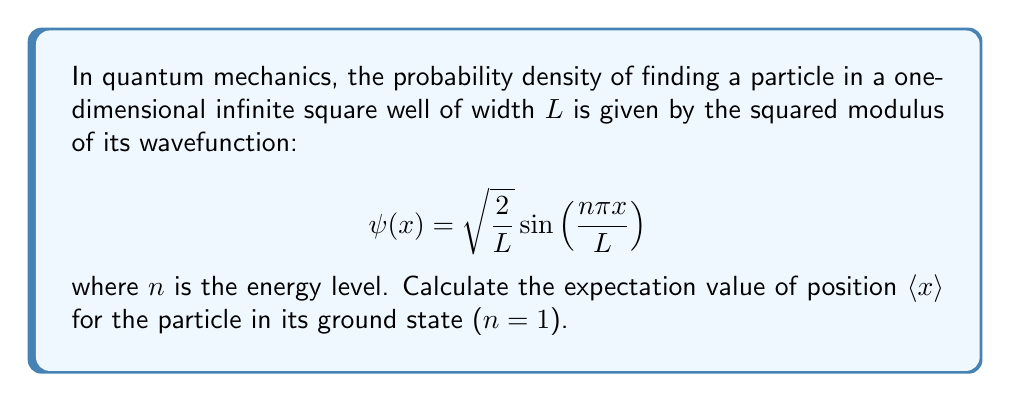What is the answer to this math problem? To solve this problem, we need to apply integration techniques from advanced calculus. Let's approach this step-by-step:

1) The expectation value of position is given by the integral:

   $$\langle x \rangle = \int_0^L x |\psi(x)|^2 dx$$

2) For the ground state ($n=1$), the wavefunction is:

   $$\psi(x) = \sqrt{\frac{2}{L}} \sin\left(\frac{\pi x}{L}\right)$$

3) Squaring this to get the probability density:

   $$|\psi(x)|^2 = \frac{2}{L} \sin^2\left(\frac{\pi x}{L}\right)$$

4) Substituting into the expectation value integral:

   $$\langle x \rangle = \int_0^L x \cdot \frac{2}{L} \sin^2\left(\frac{\pi x}{L}\right) dx$$

5) This integral can be solved using the trigonometric identity:

   $$\sin^2(\theta) = \frac{1}{2}(1 - \cos(2\theta))$$

6) Applying this identity:

   $$\langle x \rangle = \frac{2}{L} \int_0^L x \cdot \frac{1}{2}\left(1 - \cos\left(\frac{2\pi x}{L}\right)\right) dx$$

7) Simplifying:

   $$\langle x \rangle = \frac{1}{L} \int_0^L x dx - \frac{1}{L} \int_0^L x \cos\left(\frac{2\pi x}{L}\right) dx$$

8) The first integral is straightforward:

   $$\int_0^L x dx = \frac{1}{2}L^2$$

9) For the second integral, we can use integration by parts:

   $$\int_0^L x \cos\left(\frac{2\pi x}{L}\right) dx = \frac{L}{2\pi} \left[x \sin\left(\frac{2\pi x}{L}\right)\right]_0^L - \frac{L}{2\pi} \int_0^L \sin\left(\frac{2\pi x}{L}\right) dx$$

10) Evaluating this:

    $$\frac{L}{2\pi} \cdot 0 - \frac{L}{2\pi} \cdot \left[-\frac{L}{2\pi} \cos\left(\frac{2\pi x}{L}\right)\right]_0^L = 0$$

11) Therefore, the expectation value simplifies to:

    $$\langle x \rangle = \frac{1}{L} \cdot \frac{1}{2}L^2 = \frac{L}{2}$$
Answer: $\frac{L}{2}$ 